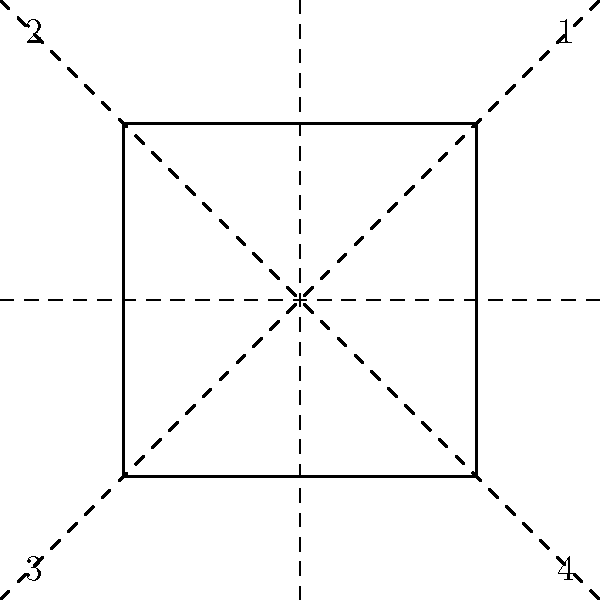Consider the symmetries of a square as shown in the figure. The group of symmetries consists of 8 elements: the identity (e), rotations by 90°, 180°, and 270° clockwise (r₁, r₂, r₃), and reflections about the horizontal, vertical, and diagonal axes (h, v, d₁, d₂). Given the following partial group table, determine the missing element X:

$$\begin{array}{c|cccccccc}
 & e & r_1 & r_2 & r_3 & h & v & d_1 & d_2 \\
\hline
e & e & r_1 & r_2 & r_3 & h & v & d_1 & d_2 \\
r_1 & r_1 & r_2 & r_3 & e & d_1 & d_2 & v & h \\
r_2 & r_2 & r_3 & e & r_1 & v & h & d_2 & d_1 \\
r_3 & r_3 & e & r_1 & r_2 & d_2 & d_1 & h & v \\
h & h & d_2 & v & d_1 & e & r_2 & r_3 & r_1 \\
v & v & d_1 & h & d_2 & r_2 & e & r_1 & r_3 \\
d_1 & d_1 & h & d_2 & v & r_1 & r_3 & e & r_2 \\
d_2 & d_2 & v & d_1 & \textbf{X} & r_3 & r_1 & r_2 & e \\
\end{array}$$ To determine the missing element X, we need to follow these steps:

1) Recall that in a group, the operation (in this case, composition of symmetries) is associative and closed.

2) The element X represents the result of composing d₂ and r₃.

3) We can find X by using the properties of the group:
   - d₂ • r₃ = X
   - r₃⁻¹ • d₂ • r₃ = r₃⁻¹ • X

4) In the group of symmetries of a square, r₃⁻¹ = r₁ (rotation by 90° clockwise is the inverse of rotation by 270° clockwise).

5) Looking at the row for r₁ in the table, we see that r₁ • d₂ = h.

6) Therefore, r₁ • d₂ • r₃ = h • r₃

7) From the row for h in the table, we can see that h • r₃ = d₁

Thus, we have determined that X = d₁.
Answer: d₁ 